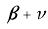Convert formula to latex. <formula><loc_0><loc_0><loc_500><loc_500>\beta + \nu</formula> 